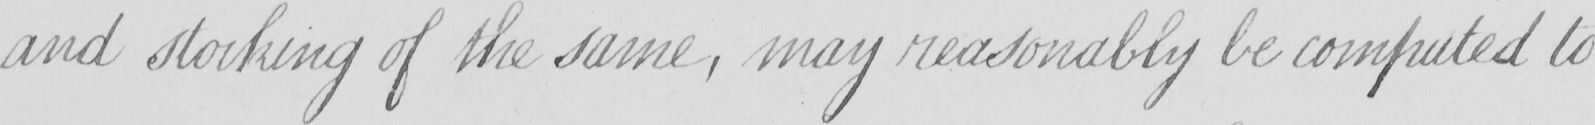What text is written in this handwritten line? and stocking of the same , may reasonably be computed to 